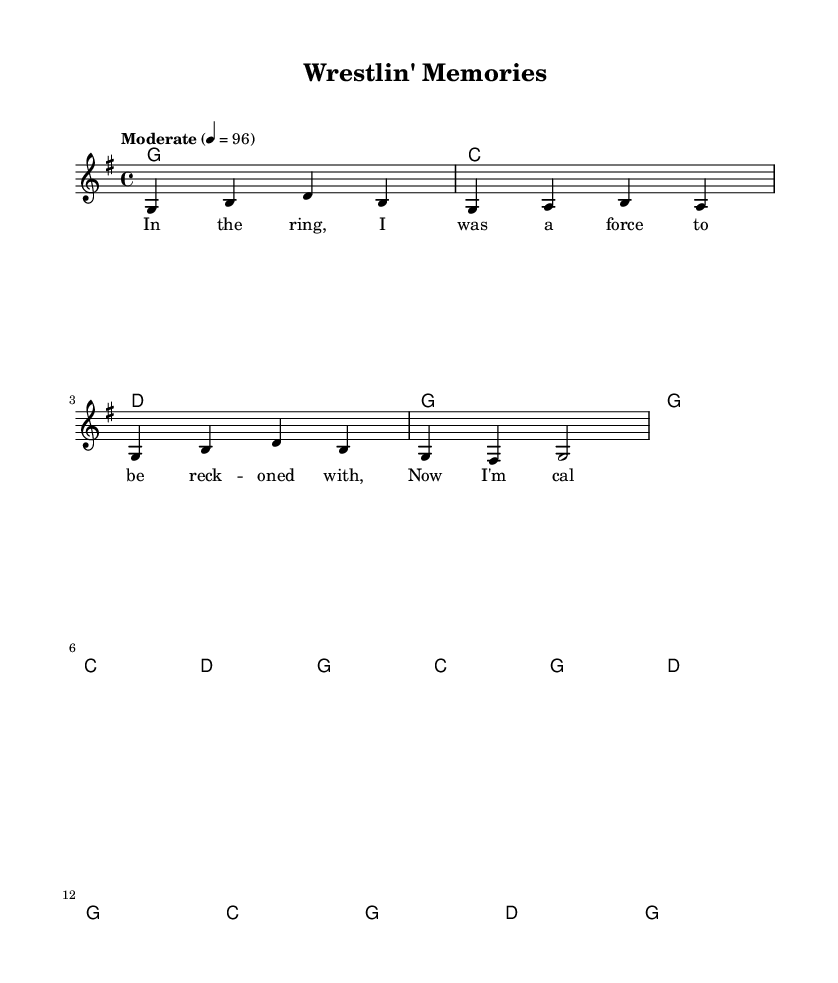What is the key signature of this music? The key signature is G major, which has one sharp (F#) and is indicated at the beginning of the staff.
Answer: G major What is the time signature of this music? The time signature is 4/4, which means there are four beats in each measure, as indicated in the notation.
Answer: 4/4 What is the tempo marking for this piece? The tempo marking shows "Moderate" with a metronome marking of 96, indicating a moderate pace for the music.
Answer: Moderate 4 = 96 How many measures are in the verse? The verse contains 8 measures, as counted from the music notation in the verse section.
Answer: 8 measures What is the first lyric line of the chorus? The first lyric line of the chorus is "Wrest-lin' mem-'ries, they're all I've got now," as presented in the lyrics below the melody.
Answer: Wrest-lin' mem-'ries, they're all I've got now Which chord appears at the beginning of the verse? The first chord of the verse is G, as indicated in the chord symbols at the start of the verse section.
Answer: G What musical style does this piece represent? The piece is categorized as a Country song, given its lyrical themes related to wrestling and the structure typical of Country music.
Answer: Country 